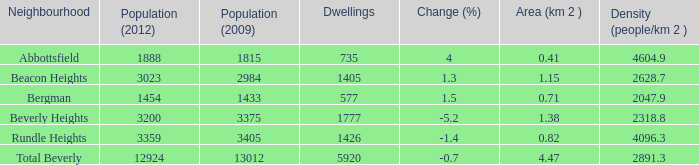How many Dwellings does Beverly Heights have that have a change percent larger than -5.2? None. 